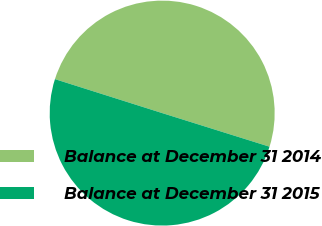Convert chart. <chart><loc_0><loc_0><loc_500><loc_500><pie_chart><fcel>Balance at December 31 2014<fcel>Balance at December 31 2015<nl><fcel>49.95%<fcel>50.05%<nl></chart> 